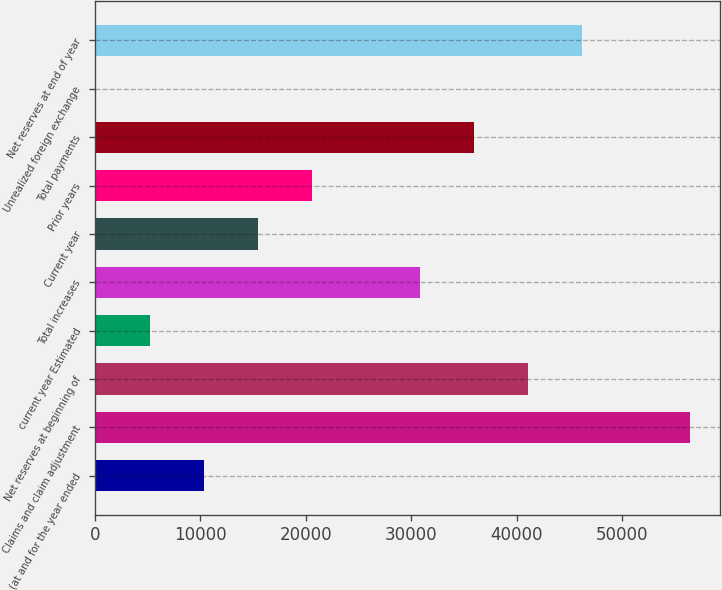<chart> <loc_0><loc_0><loc_500><loc_500><bar_chart><fcel>(at and for the year ended<fcel>Claims and claim adjustment<fcel>Net reserves at beginning of<fcel>current year Estimated<fcel>Total increases<fcel>Current year<fcel>Prior years<fcel>Total payments<fcel>Unrealized foreign exchange<fcel>Net reserves at end of year<nl><fcel>10321<fcel>56482<fcel>41095<fcel>5192<fcel>30837<fcel>15450<fcel>20579<fcel>35966<fcel>63<fcel>46224<nl></chart> 